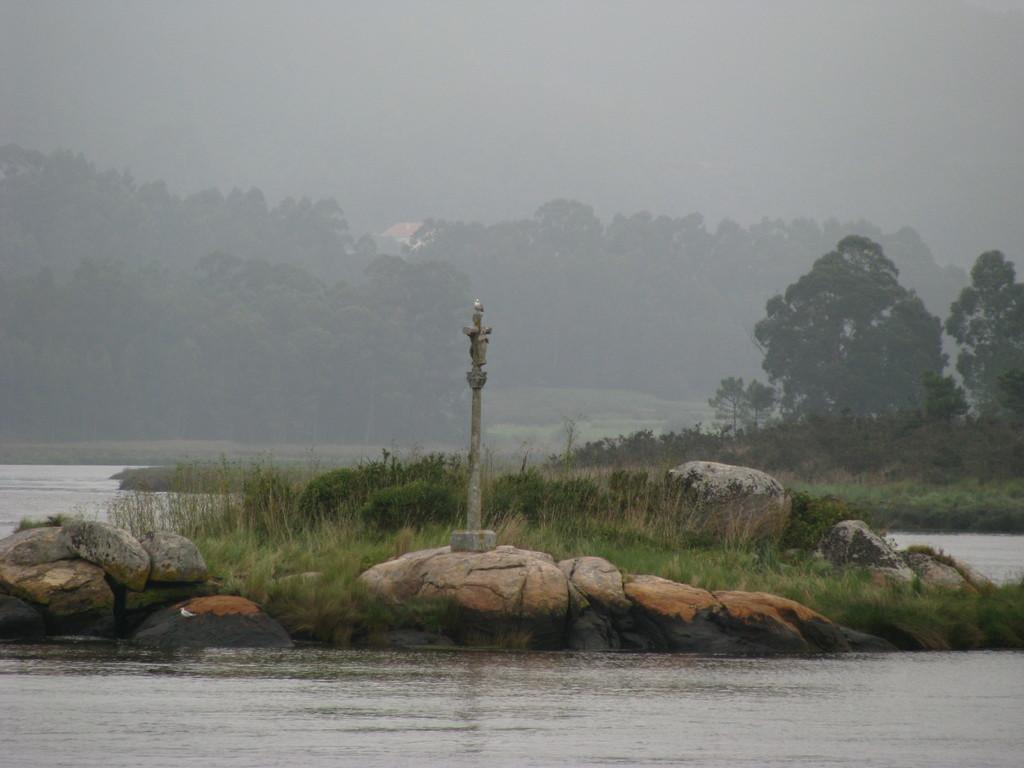Could you give a brief overview of what you see in this image? Front we can see water. Background there are trees, plants and grass. 